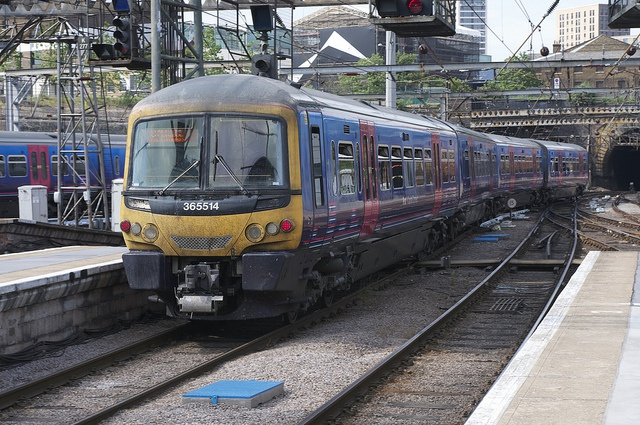Describe the objects in this image and their specific colors. I can see train in black, gray, and darkgray tones, train in black, navy, blue, darkgray, and gray tones, traffic light in black, maroon, and gray tones, traffic light in black and gray tones, and traffic light in black and gray tones in this image. 